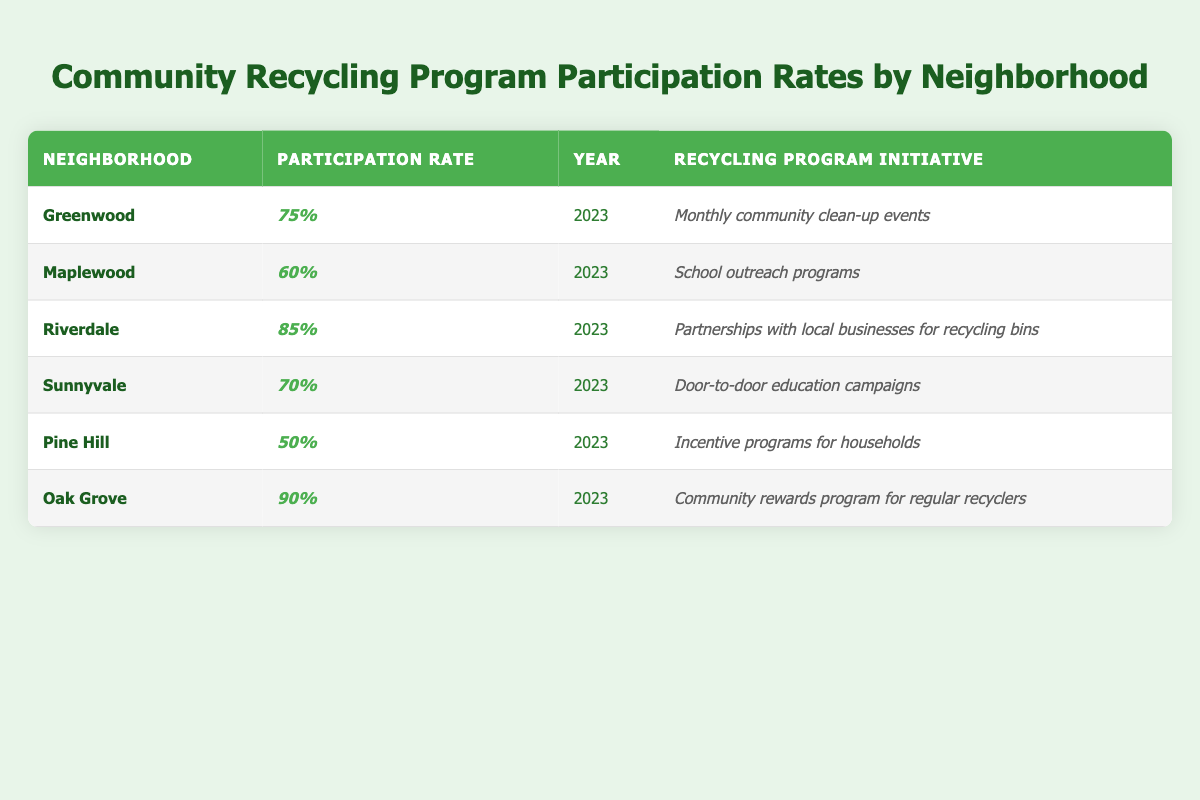What is the participation rate for Riverdale? The table shows that the participation rate for Riverdale is listed as 85%.
Answer: 85% Which neighborhood has the lowest participation rate? Looking at the participation rates, Pine Hill has the lowest rate at 50%.
Answer: Pine Hill What is the recycling program initiative for Greenwood? The initiative for Greenwood is "Monthly community clean-up events," as stated in the table.
Answer: Monthly community clean-up events Is the participation rate in Sunnyvale higher than in Maplewood? Sunnyvale's participation rate is 70%, whereas Maplewood's is 60%. Therefore, Sunnyvale has a higher participation rate.
Answer: Yes What is the difference in participation rates between Oak Grove and Pine Hill? Oak Grove has a participation rate of 90% while Pine Hill has 50%. The difference is 90% - 50% = 40%.
Answer: 40% What is the average participation rate across all neighborhoods listed? The participation rates are 75%, 60%, 85%, 70%, 50%, and 90%. Adding these up gives 75 + 60 + 85 + 70 + 50 + 90 = 430. Dividing by 6 (the number of neighborhoods), the average is 430 / 6 = approximately 71.67%.
Answer: 71.67% Which neighborhood has a recycling program initiative focused on businesses? The table shows that Riverdale has an initiative for "Partnerships with local businesses for recycling bins."
Answer: Riverdale Are there any neighborhoods with a participation rate of 80% or higher? By checking the participation rates, both Riverdale (85%) and Oak Grove (90%) are above 80%.
Answer: Yes How many neighborhoods have a participation rate of 70% or lower? The neighborhoods with 70% or lower are Maplewood (60%), Sunnyvale (70%), and Pine Hill (50%). That makes three neighborhoods.
Answer: 3 What is the recycling program initiative in Oak Grove? The initiative for Oak Grove is "Community rewards program for regular recyclers," as per the table.
Answer: Community rewards program for regular recyclers 